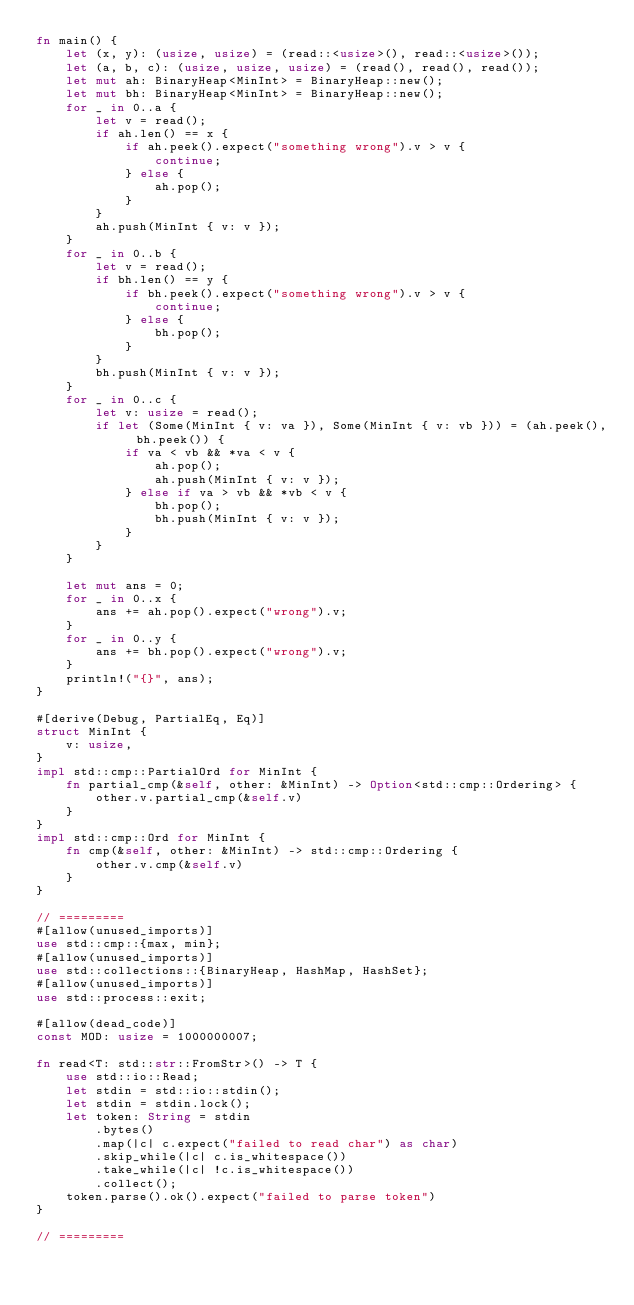Convert code to text. <code><loc_0><loc_0><loc_500><loc_500><_Rust_>fn main() {
    let (x, y): (usize, usize) = (read::<usize>(), read::<usize>());
    let (a, b, c): (usize, usize, usize) = (read(), read(), read());
    let mut ah: BinaryHeap<MinInt> = BinaryHeap::new();
    let mut bh: BinaryHeap<MinInt> = BinaryHeap::new();
    for _ in 0..a {
        let v = read();
        if ah.len() == x {
            if ah.peek().expect("something wrong").v > v {
                continue;
            } else {
                ah.pop();
            }
        }
        ah.push(MinInt { v: v });
    }
    for _ in 0..b {
        let v = read();
        if bh.len() == y {
            if bh.peek().expect("something wrong").v > v {
                continue;
            } else {
                bh.pop();
            }
        }
        bh.push(MinInt { v: v });
    }
    for _ in 0..c {
        let v: usize = read();
        if let (Some(MinInt { v: va }), Some(MinInt { v: vb })) = (ah.peek(), bh.peek()) {
            if va < vb && *va < v {
                ah.pop();
                ah.push(MinInt { v: v });
            } else if va > vb && *vb < v {
                bh.pop();
                bh.push(MinInt { v: v });
            }
        }
    }

    let mut ans = 0;
    for _ in 0..x {
        ans += ah.pop().expect("wrong").v;
    }
    for _ in 0..y {
        ans += bh.pop().expect("wrong").v;
    }
    println!("{}", ans);
}

#[derive(Debug, PartialEq, Eq)]
struct MinInt {
    v: usize,
}
impl std::cmp::PartialOrd for MinInt {
    fn partial_cmp(&self, other: &MinInt) -> Option<std::cmp::Ordering> {
        other.v.partial_cmp(&self.v)
    }
}
impl std::cmp::Ord for MinInt {
    fn cmp(&self, other: &MinInt) -> std::cmp::Ordering {
        other.v.cmp(&self.v)
    }
}

// =========
#[allow(unused_imports)]
use std::cmp::{max, min};
#[allow(unused_imports)]
use std::collections::{BinaryHeap, HashMap, HashSet};
#[allow(unused_imports)]
use std::process::exit;

#[allow(dead_code)]
const MOD: usize = 1000000007;

fn read<T: std::str::FromStr>() -> T {
    use std::io::Read;
    let stdin = std::io::stdin();
    let stdin = stdin.lock();
    let token: String = stdin
        .bytes()
        .map(|c| c.expect("failed to read char") as char)
        .skip_while(|c| c.is_whitespace())
        .take_while(|c| !c.is_whitespace())
        .collect();
    token.parse().ok().expect("failed to parse token")
}

// =========
</code> 